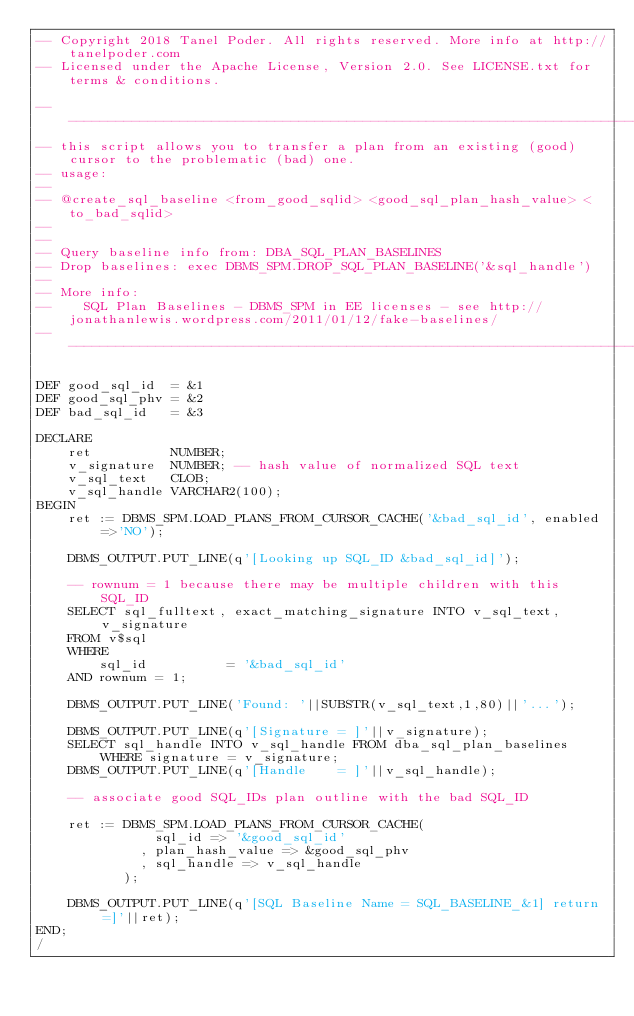Convert code to text. <code><loc_0><loc_0><loc_500><loc_500><_SQL_>-- Copyright 2018 Tanel Poder. All rights reserved. More info at http://tanelpoder.com
-- Licensed under the Apache License, Version 2.0. See LICENSE.txt for terms & conditions.

--------------------------------------------------------------------------------------------------------
-- this script allows you to transfer a plan from an existing (good) cursor to the problematic (bad) one.
-- usage:
--
-- @create_sql_baseline <from_good_sqlid> <good_sql_plan_hash_value> <to_bad_sqlid>
--
--
-- Query baseline info from: DBA_SQL_PLAN_BASELINES
-- Drop baselines: exec DBMS_SPM.DROP_SQL_PLAN_BASELINE('&sql_handle')
--
-- More info:
--    SQL Plan Baselines - DBMS_SPM in EE licenses - see http://jonathanlewis.wordpress.com/2011/01/12/fake-baselines/
--------------------------------------------------------------------------------------------------------

DEF good_sql_id  = &1
DEF good_sql_phv = &2
DEF bad_sql_id   = &3

DECLARE
    ret          NUMBER;
    v_signature  NUMBER; -- hash value of normalized SQL text
    v_sql_text   CLOB;
    v_sql_handle VARCHAR2(100);
BEGIN
    ret := DBMS_SPM.LOAD_PLANS_FROM_CURSOR_CACHE('&bad_sql_id', enabled=>'NO');
    
    DBMS_OUTPUT.PUT_LINE(q'[Looking up SQL_ID &bad_sql_id]');

    -- rownum = 1 because there may be multiple children with this SQL_ID
    SELECT sql_fulltext, exact_matching_signature INTO v_sql_text, v_signature 
    FROM v$sql 
    WHERE 
        sql_id          = '&bad_sql_id' 
    AND rownum = 1;

    DBMS_OUTPUT.PUT_LINE('Found: '||SUBSTR(v_sql_text,1,80)||'...');

    DBMS_OUTPUT.PUT_LINE(q'[Signature = ]'||v_signature);
    SELECT sql_handle INTO v_sql_handle FROM dba_sql_plan_baselines WHERE signature = v_signature;
    DBMS_OUTPUT.PUT_LINE(q'[Handle    = ]'||v_sql_handle);

    -- associate good SQL_IDs plan outline with the bad SQL_ID

    ret := DBMS_SPM.LOAD_PLANS_FROM_CURSOR_CACHE(
               sql_id => '&good_sql_id'
             , plan_hash_value => &good_sql_phv
             , sql_handle => v_sql_handle
           );

    DBMS_OUTPUT.PUT_LINE(q'[SQL Baseline Name = SQL_BASELINE_&1] return=]'||ret);
END;
/

</code> 